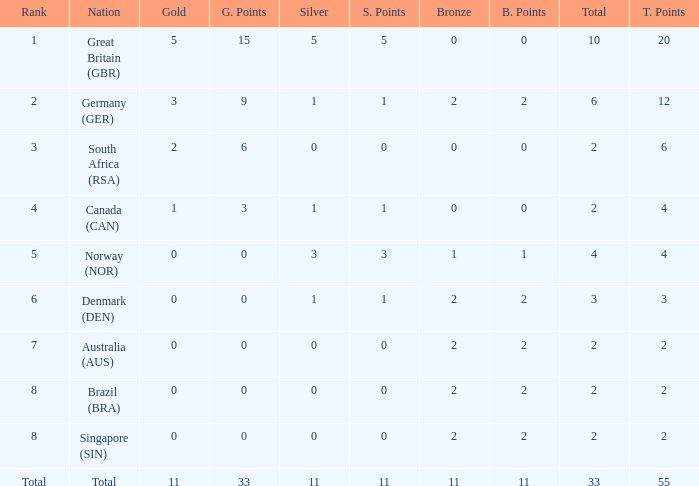What is the least total when the nation is canada (can) and bronze is less than 0? None. 